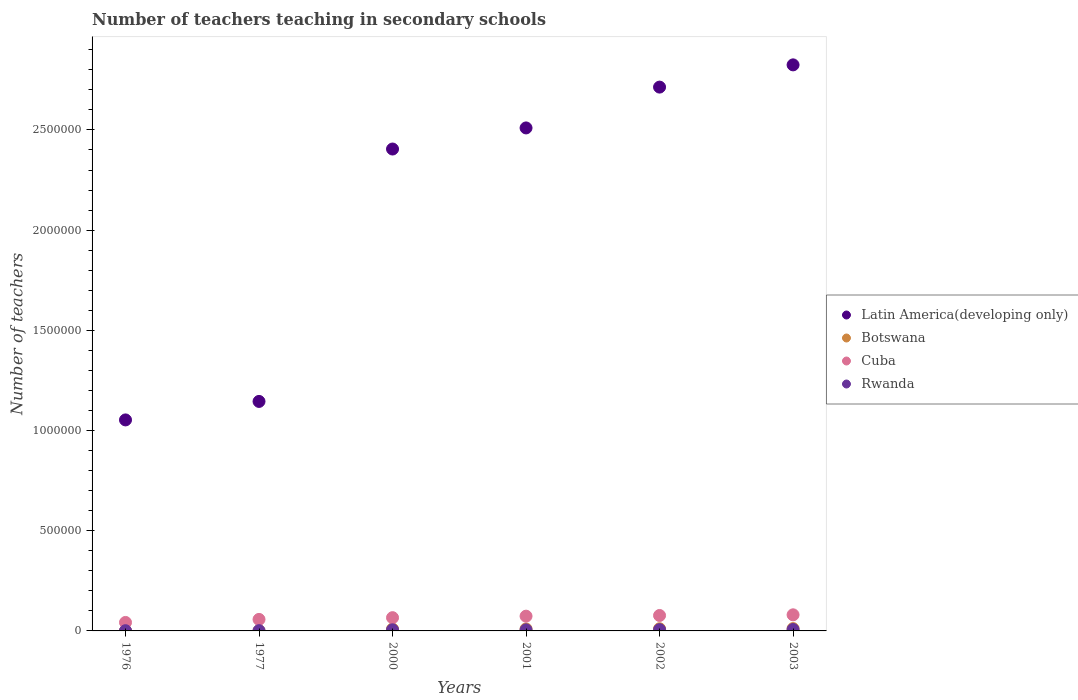How many different coloured dotlines are there?
Offer a very short reply. 4. What is the number of teachers teaching in secondary schools in Rwanda in 2002?
Offer a terse response. 6329. Across all years, what is the maximum number of teachers teaching in secondary schools in Botswana?
Offer a terse response. 1.16e+04. Across all years, what is the minimum number of teachers teaching in secondary schools in Latin America(developing only)?
Your answer should be compact. 1.05e+06. In which year was the number of teachers teaching in secondary schools in Botswana minimum?
Your response must be concise. 1976. What is the total number of teachers teaching in secondary schools in Cuba in the graph?
Give a very brief answer. 3.97e+05. What is the difference between the number of teachers teaching in secondary schools in Botswana in 1976 and that in 2002?
Ensure brevity in your answer.  -9895. What is the difference between the number of teachers teaching in secondary schools in Cuba in 2002 and the number of teachers teaching in secondary schools in Latin America(developing only) in 1976?
Your answer should be very brief. -9.76e+05. What is the average number of teachers teaching in secondary schools in Latin America(developing only) per year?
Give a very brief answer. 2.11e+06. In the year 1976, what is the difference between the number of teachers teaching in secondary schools in Rwanda and number of teachers teaching in secondary schools in Botswana?
Your answer should be compact. 213. In how many years, is the number of teachers teaching in secondary schools in Rwanda greater than 2300000?
Give a very brief answer. 0. What is the ratio of the number of teachers teaching in secondary schools in Cuba in 1976 to that in 2003?
Provide a succinct answer. 0.53. Is the number of teachers teaching in secondary schools in Rwanda in 1977 less than that in 2001?
Your answer should be compact. Yes. Is the difference between the number of teachers teaching in secondary schools in Rwanda in 1977 and 2003 greater than the difference between the number of teachers teaching in secondary schools in Botswana in 1977 and 2003?
Make the answer very short. Yes. What is the difference between the highest and the second highest number of teachers teaching in secondary schools in Rwanda?
Your answer should be very brief. 729. What is the difference between the highest and the lowest number of teachers teaching in secondary schools in Cuba?
Keep it short and to the point. 3.81e+04. In how many years, is the number of teachers teaching in secondary schools in Cuba greater than the average number of teachers teaching in secondary schools in Cuba taken over all years?
Make the answer very short. 3. Is it the case that in every year, the sum of the number of teachers teaching in secondary schools in Rwanda and number of teachers teaching in secondary schools in Latin America(developing only)  is greater than the number of teachers teaching in secondary schools in Botswana?
Keep it short and to the point. Yes. Does the number of teachers teaching in secondary schools in Cuba monotonically increase over the years?
Provide a succinct answer. Yes. Is the number of teachers teaching in secondary schools in Botswana strictly greater than the number of teachers teaching in secondary schools in Rwanda over the years?
Your response must be concise. No. How many years are there in the graph?
Give a very brief answer. 6. Are the values on the major ticks of Y-axis written in scientific E-notation?
Your response must be concise. No. What is the title of the graph?
Provide a short and direct response. Number of teachers teaching in secondary schools. Does "France" appear as one of the legend labels in the graph?
Keep it short and to the point. No. What is the label or title of the Y-axis?
Ensure brevity in your answer.  Number of teachers. What is the Number of teachers in Latin America(developing only) in 1976?
Ensure brevity in your answer.  1.05e+06. What is the Number of teachers of Botswana in 1976?
Ensure brevity in your answer.  920. What is the Number of teachers of Cuba in 1976?
Your answer should be compact. 4.23e+04. What is the Number of teachers in Rwanda in 1976?
Provide a short and direct response. 1133. What is the Number of teachers in Latin America(developing only) in 1977?
Keep it short and to the point. 1.15e+06. What is the Number of teachers of Botswana in 1977?
Keep it short and to the point. 928. What is the Number of teachers of Cuba in 1977?
Your answer should be compact. 5.75e+04. What is the Number of teachers of Rwanda in 1977?
Offer a terse response. 1285. What is the Number of teachers of Latin America(developing only) in 2000?
Give a very brief answer. 2.40e+06. What is the Number of teachers of Botswana in 2000?
Give a very brief answer. 9406. What is the Number of teachers of Cuba in 2000?
Your response must be concise. 6.61e+04. What is the Number of teachers in Rwanda in 2000?
Your answer should be very brief. 5557. What is the Number of teachers in Latin America(developing only) in 2001?
Offer a very short reply. 2.51e+06. What is the Number of teachers of Botswana in 2001?
Give a very brief answer. 9784. What is the Number of teachers in Cuba in 2001?
Make the answer very short. 7.36e+04. What is the Number of teachers of Rwanda in 2001?
Offer a very short reply. 5453. What is the Number of teachers in Latin America(developing only) in 2002?
Your response must be concise. 2.71e+06. What is the Number of teachers of Botswana in 2002?
Ensure brevity in your answer.  1.08e+04. What is the Number of teachers of Cuba in 2002?
Your answer should be very brief. 7.70e+04. What is the Number of teachers of Rwanda in 2002?
Give a very brief answer. 6329. What is the Number of teachers of Latin America(developing only) in 2003?
Ensure brevity in your answer.  2.82e+06. What is the Number of teachers in Botswana in 2003?
Your answer should be compact. 1.16e+04. What is the Number of teachers of Cuba in 2003?
Your response must be concise. 8.04e+04. What is the Number of teachers in Rwanda in 2003?
Your answer should be compact. 7058. Across all years, what is the maximum Number of teachers of Latin America(developing only)?
Offer a very short reply. 2.82e+06. Across all years, what is the maximum Number of teachers of Botswana?
Provide a succinct answer. 1.16e+04. Across all years, what is the maximum Number of teachers of Cuba?
Keep it short and to the point. 8.04e+04. Across all years, what is the maximum Number of teachers in Rwanda?
Make the answer very short. 7058. Across all years, what is the minimum Number of teachers in Latin America(developing only)?
Offer a terse response. 1.05e+06. Across all years, what is the minimum Number of teachers in Botswana?
Offer a terse response. 920. Across all years, what is the minimum Number of teachers of Cuba?
Offer a very short reply. 4.23e+04. Across all years, what is the minimum Number of teachers in Rwanda?
Ensure brevity in your answer.  1133. What is the total Number of teachers of Latin America(developing only) in the graph?
Offer a terse response. 1.27e+07. What is the total Number of teachers in Botswana in the graph?
Your answer should be compact. 4.35e+04. What is the total Number of teachers of Cuba in the graph?
Keep it short and to the point. 3.97e+05. What is the total Number of teachers of Rwanda in the graph?
Make the answer very short. 2.68e+04. What is the difference between the Number of teachers of Latin America(developing only) in 1976 and that in 1977?
Your answer should be very brief. -9.23e+04. What is the difference between the Number of teachers in Botswana in 1976 and that in 1977?
Provide a succinct answer. -8. What is the difference between the Number of teachers in Cuba in 1976 and that in 1977?
Offer a terse response. -1.52e+04. What is the difference between the Number of teachers of Rwanda in 1976 and that in 1977?
Give a very brief answer. -152. What is the difference between the Number of teachers in Latin America(developing only) in 1976 and that in 2000?
Offer a terse response. -1.35e+06. What is the difference between the Number of teachers of Botswana in 1976 and that in 2000?
Give a very brief answer. -8486. What is the difference between the Number of teachers of Cuba in 1976 and that in 2000?
Ensure brevity in your answer.  -2.38e+04. What is the difference between the Number of teachers in Rwanda in 1976 and that in 2000?
Offer a terse response. -4424. What is the difference between the Number of teachers of Latin America(developing only) in 1976 and that in 2001?
Give a very brief answer. -1.46e+06. What is the difference between the Number of teachers of Botswana in 1976 and that in 2001?
Your response must be concise. -8864. What is the difference between the Number of teachers of Cuba in 1976 and that in 2001?
Keep it short and to the point. -3.13e+04. What is the difference between the Number of teachers in Rwanda in 1976 and that in 2001?
Make the answer very short. -4320. What is the difference between the Number of teachers in Latin America(developing only) in 1976 and that in 2002?
Your answer should be very brief. -1.66e+06. What is the difference between the Number of teachers in Botswana in 1976 and that in 2002?
Offer a terse response. -9895. What is the difference between the Number of teachers in Cuba in 1976 and that in 2002?
Ensure brevity in your answer.  -3.47e+04. What is the difference between the Number of teachers in Rwanda in 1976 and that in 2002?
Make the answer very short. -5196. What is the difference between the Number of teachers of Latin America(developing only) in 1976 and that in 2003?
Your response must be concise. -1.77e+06. What is the difference between the Number of teachers in Botswana in 1976 and that in 2003?
Keep it short and to the point. -1.07e+04. What is the difference between the Number of teachers of Cuba in 1976 and that in 2003?
Provide a succinct answer. -3.81e+04. What is the difference between the Number of teachers in Rwanda in 1976 and that in 2003?
Offer a very short reply. -5925. What is the difference between the Number of teachers in Latin America(developing only) in 1977 and that in 2000?
Your response must be concise. -1.26e+06. What is the difference between the Number of teachers of Botswana in 1977 and that in 2000?
Your response must be concise. -8478. What is the difference between the Number of teachers in Cuba in 1977 and that in 2000?
Give a very brief answer. -8645. What is the difference between the Number of teachers of Rwanda in 1977 and that in 2000?
Your answer should be compact. -4272. What is the difference between the Number of teachers of Latin America(developing only) in 1977 and that in 2001?
Offer a very short reply. -1.36e+06. What is the difference between the Number of teachers in Botswana in 1977 and that in 2001?
Provide a succinct answer. -8856. What is the difference between the Number of teachers in Cuba in 1977 and that in 2001?
Your response must be concise. -1.62e+04. What is the difference between the Number of teachers in Rwanda in 1977 and that in 2001?
Your answer should be very brief. -4168. What is the difference between the Number of teachers in Latin America(developing only) in 1977 and that in 2002?
Your answer should be very brief. -1.57e+06. What is the difference between the Number of teachers in Botswana in 1977 and that in 2002?
Offer a very short reply. -9887. What is the difference between the Number of teachers of Cuba in 1977 and that in 2002?
Your response must be concise. -1.96e+04. What is the difference between the Number of teachers in Rwanda in 1977 and that in 2002?
Provide a short and direct response. -5044. What is the difference between the Number of teachers of Latin America(developing only) in 1977 and that in 2003?
Your answer should be compact. -1.68e+06. What is the difference between the Number of teachers of Botswana in 1977 and that in 2003?
Your response must be concise. -1.07e+04. What is the difference between the Number of teachers of Cuba in 1977 and that in 2003?
Offer a terse response. -2.29e+04. What is the difference between the Number of teachers of Rwanda in 1977 and that in 2003?
Your answer should be very brief. -5773. What is the difference between the Number of teachers of Latin America(developing only) in 2000 and that in 2001?
Provide a short and direct response. -1.05e+05. What is the difference between the Number of teachers of Botswana in 2000 and that in 2001?
Your answer should be compact. -378. What is the difference between the Number of teachers of Cuba in 2000 and that in 2001?
Make the answer very short. -7505. What is the difference between the Number of teachers of Rwanda in 2000 and that in 2001?
Provide a succinct answer. 104. What is the difference between the Number of teachers of Latin America(developing only) in 2000 and that in 2002?
Keep it short and to the point. -3.09e+05. What is the difference between the Number of teachers of Botswana in 2000 and that in 2002?
Offer a very short reply. -1409. What is the difference between the Number of teachers of Cuba in 2000 and that in 2002?
Ensure brevity in your answer.  -1.09e+04. What is the difference between the Number of teachers in Rwanda in 2000 and that in 2002?
Your answer should be very brief. -772. What is the difference between the Number of teachers of Latin America(developing only) in 2000 and that in 2003?
Give a very brief answer. -4.20e+05. What is the difference between the Number of teachers in Botswana in 2000 and that in 2003?
Keep it short and to the point. -2234. What is the difference between the Number of teachers of Cuba in 2000 and that in 2003?
Provide a succinct answer. -1.42e+04. What is the difference between the Number of teachers of Rwanda in 2000 and that in 2003?
Your answer should be very brief. -1501. What is the difference between the Number of teachers in Latin America(developing only) in 2001 and that in 2002?
Your answer should be compact. -2.04e+05. What is the difference between the Number of teachers in Botswana in 2001 and that in 2002?
Offer a terse response. -1031. What is the difference between the Number of teachers of Cuba in 2001 and that in 2002?
Offer a terse response. -3414. What is the difference between the Number of teachers of Rwanda in 2001 and that in 2002?
Your response must be concise. -876. What is the difference between the Number of teachers of Latin America(developing only) in 2001 and that in 2003?
Your answer should be compact. -3.15e+05. What is the difference between the Number of teachers in Botswana in 2001 and that in 2003?
Provide a succinct answer. -1856. What is the difference between the Number of teachers of Cuba in 2001 and that in 2003?
Provide a succinct answer. -6745. What is the difference between the Number of teachers of Rwanda in 2001 and that in 2003?
Your answer should be compact. -1605. What is the difference between the Number of teachers in Latin America(developing only) in 2002 and that in 2003?
Give a very brief answer. -1.11e+05. What is the difference between the Number of teachers of Botswana in 2002 and that in 2003?
Make the answer very short. -825. What is the difference between the Number of teachers of Cuba in 2002 and that in 2003?
Your answer should be very brief. -3331. What is the difference between the Number of teachers in Rwanda in 2002 and that in 2003?
Provide a succinct answer. -729. What is the difference between the Number of teachers of Latin America(developing only) in 1976 and the Number of teachers of Botswana in 1977?
Give a very brief answer. 1.05e+06. What is the difference between the Number of teachers of Latin America(developing only) in 1976 and the Number of teachers of Cuba in 1977?
Offer a terse response. 9.96e+05. What is the difference between the Number of teachers of Latin America(developing only) in 1976 and the Number of teachers of Rwanda in 1977?
Your response must be concise. 1.05e+06. What is the difference between the Number of teachers of Botswana in 1976 and the Number of teachers of Cuba in 1977?
Offer a terse response. -5.66e+04. What is the difference between the Number of teachers of Botswana in 1976 and the Number of teachers of Rwanda in 1977?
Offer a terse response. -365. What is the difference between the Number of teachers of Cuba in 1976 and the Number of teachers of Rwanda in 1977?
Your answer should be compact. 4.10e+04. What is the difference between the Number of teachers in Latin America(developing only) in 1976 and the Number of teachers in Botswana in 2000?
Your answer should be very brief. 1.04e+06. What is the difference between the Number of teachers of Latin America(developing only) in 1976 and the Number of teachers of Cuba in 2000?
Offer a terse response. 9.87e+05. What is the difference between the Number of teachers in Latin America(developing only) in 1976 and the Number of teachers in Rwanda in 2000?
Your answer should be very brief. 1.05e+06. What is the difference between the Number of teachers in Botswana in 1976 and the Number of teachers in Cuba in 2000?
Your response must be concise. -6.52e+04. What is the difference between the Number of teachers in Botswana in 1976 and the Number of teachers in Rwanda in 2000?
Your response must be concise. -4637. What is the difference between the Number of teachers of Cuba in 1976 and the Number of teachers of Rwanda in 2000?
Offer a terse response. 3.67e+04. What is the difference between the Number of teachers of Latin America(developing only) in 1976 and the Number of teachers of Botswana in 2001?
Offer a very short reply. 1.04e+06. What is the difference between the Number of teachers of Latin America(developing only) in 1976 and the Number of teachers of Cuba in 2001?
Offer a very short reply. 9.79e+05. What is the difference between the Number of teachers in Latin America(developing only) in 1976 and the Number of teachers in Rwanda in 2001?
Offer a terse response. 1.05e+06. What is the difference between the Number of teachers in Botswana in 1976 and the Number of teachers in Cuba in 2001?
Keep it short and to the point. -7.27e+04. What is the difference between the Number of teachers of Botswana in 1976 and the Number of teachers of Rwanda in 2001?
Provide a short and direct response. -4533. What is the difference between the Number of teachers in Cuba in 1976 and the Number of teachers in Rwanda in 2001?
Ensure brevity in your answer.  3.69e+04. What is the difference between the Number of teachers in Latin America(developing only) in 1976 and the Number of teachers in Botswana in 2002?
Provide a short and direct response. 1.04e+06. What is the difference between the Number of teachers of Latin America(developing only) in 1976 and the Number of teachers of Cuba in 2002?
Keep it short and to the point. 9.76e+05. What is the difference between the Number of teachers in Latin America(developing only) in 1976 and the Number of teachers in Rwanda in 2002?
Make the answer very short. 1.05e+06. What is the difference between the Number of teachers of Botswana in 1976 and the Number of teachers of Cuba in 2002?
Offer a very short reply. -7.61e+04. What is the difference between the Number of teachers in Botswana in 1976 and the Number of teachers in Rwanda in 2002?
Give a very brief answer. -5409. What is the difference between the Number of teachers of Cuba in 1976 and the Number of teachers of Rwanda in 2002?
Provide a succinct answer. 3.60e+04. What is the difference between the Number of teachers in Latin America(developing only) in 1976 and the Number of teachers in Botswana in 2003?
Provide a short and direct response. 1.04e+06. What is the difference between the Number of teachers of Latin America(developing only) in 1976 and the Number of teachers of Cuba in 2003?
Ensure brevity in your answer.  9.73e+05. What is the difference between the Number of teachers in Latin America(developing only) in 1976 and the Number of teachers in Rwanda in 2003?
Your answer should be compact. 1.05e+06. What is the difference between the Number of teachers in Botswana in 1976 and the Number of teachers in Cuba in 2003?
Make the answer very short. -7.95e+04. What is the difference between the Number of teachers of Botswana in 1976 and the Number of teachers of Rwanda in 2003?
Ensure brevity in your answer.  -6138. What is the difference between the Number of teachers of Cuba in 1976 and the Number of teachers of Rwanda in 2003?
Provide a short and direct response. 3.52e+04. What is the difference between the Number of teachers of Latin America(developing only) in 1977 and the Number of teachers of Botswana in 2000?
Ensure brevity in your answer.  1.14e+06. What is the difference between the Number of teachers of Latin America(developing only) in 1977 and the Number of teachers of Cuba in 2000?
Provide a succinct answer. 1.08e+06. What is the difference between the Number of teachers of Latin America(developing only) in 1977 and the Number of teachers of Rwanda in 2000?
Provide a short and direct response. 1.14e+06. What is the difference between the Number of teachers of Botswana in 1977 and the Number of teachers of Cuba in 2000?
Offer a terse response. -6.52e+04. What is the difference between the Number of teachers of Botswana in 1977 and the Number of teachers of Rwanda in 2000?
Offer a terse response. -4629. What is the difference between the Number of teachers in Cuba in 1977 and the Number of teachers in Rwanda in 2000?
Make the answer very short. 5.19e+04. What is the difference between the Number of teachers in Latin America(developing only) in 1977 and the Number of teachers in Botswana in 2001?
Provide a short and direct response. 1.14e+06. What is the difference between the Number of teachers of Latin America(developing only) in 1977 and the Number of teachers of Cuba in 2001?
Provide a succinct answer. 1.07e+06. What is the difference between the Number of teachers of Latin America(developing only) in 1977 and the Number of teachers of Rwanda in 2001?
Your answer should be very brief. 1.14e+06. What is the difference between the Number of teachers in Botswana in 1977 and the Number of teachers in Cuba in 2001?
Provide a succinct answer. -7.27e+04. What is the difference between the Number of teachers of Botswana in 1977 and the Number of teachers of Rwanda in 2001?
Offer a terse response. -4525. What is the difference between the Number of teachers of Cuba in 1977 and the Number of teachers of Rwanda in 2001?
Provide a succinct answer. 5.20e+04. What is the difference between the Number of teachers of Latin America(developing only) in 1977 and the Number of teachers of Botswana in 2002?
Your response must be concise. 1.13e+06. What is the difference between the Number of teachers in Latin America(developing only) in 1977 and the Number of teachers in Cuba in 2002?
Your answer should be very brief. 1.07e+06. What is the difference between the Number of teachers in Latin America(developing only) in 1977 and the Number of teachers in Rwanda in 2002?
Provide a short and direct response. 1.14e+06. What is the difference between the Number of teachers of Botswana in 1977 and the Number of teachers of Cuba in 2002?
Ensure brevity in your answer.  -7.61e+04. What is the difference between the Number of teachers in Botswana in 1977 and the Number of teachers in Rwanda in 2002?
Your answer should be compact. -5401. What is the difference between the Number of teachers in Cuba in 1977 and the Number of teachers in Rwanda in 2002?
Make the answer very short. 5.11e+04. What is the difference between the Number of teachers in Latin America(developing only) in 1977 and the Number of teachers in Botswana in 2003?
Make the answer very short. 1.13e+06. What is the difference between the Number of teachers in Latin America(developing only) in 1977 and the Number of teachers in Cuba in 2003?
Keep it short and to the point. 1.06e+06. What is the difference between the Number of teachers of Latin America(developing only) in 1977 and the Number of teachers of Rwanda in 2003?
Keep it short and to the point. 1.14e+06. What is the difference between the Number of teachers in Botswana in 1977 and the Number of teachers in Cuba in 2003?
Your response must be concise. -7.94e+04. What is the difference between the Number of teachers of Botswana in 1977 and the Number of teachers of Rwanda in 2003?
Your answer should be very brief. -6130. What is the difference between the Number of teachers of Cuba in 1977 and the Number of teachers of Rwanda in 2003?
Your answer should be very brief. 5.04e+04. What is the difference between the Number of teachers of Latin America(developing only) in 2000 and the Number of teachers of Botswana in 2001?
Offer a terse response. 2.40e+06. What is the difference between the Number of teachers of Latin America(developing only) in 2000 and the Number of teachers of Cuba in 2001?
Provide a short and direct response. 2.33e+06. What is the difference between the Number of teachers of Latin America(developing only) in 2000 and the Number of teachers of Rwanda in 2001?
Offer a very short reply. 2.40e+06. What is the difference between the Number of teachers in Botswana in 2000 and the Number of teachers in Cuba in 2001?
Make the answer very short. -6.42e+04. What is the difference between the Number of teachers of Botswana in 2000 and the Number of teachers of Rwanda in 2001?
Your answer should be very brief. 3953. What is the difference between the Number of teachers in Cuba in 2000 and the Number of teachers in Rwanda in 2001?
Provide a short and direct response. 6.07e+04. What is the difference between the Number of teachers in Latin America(developing only) in 2000 and the Number of teachers in Botswana in 2002?
Your answer should be compact. 2.39e+06. What is the difference between the Number of teachers in Latin America(developing only) in 2000 and the Number of teachers in Cuba in 2002?
Offer a very short reply. 2.33e+06. What is the difference between the Number of teachers of Latin America(developing only) in 2000 and the Number of teachers of Rwanda in 2002?
Your answer should be very brief. 2.40e+06. What is the difference between the Number of teachers in Botswana in 2000 and the Number of teachers in Cuba in 2002?
Ensure brevity in your answer.  -6.76e+04. What is the difference between the Number of teachers of Botswana in 2000 and the Number of teachers of Rwanda in 2002?
Offer a terse response. 3077. What is the difference between the Number of teachers of Cuba in 2000 and the Number of teachers of Rwanda in 2002?
Ensure brevity in your answer.  5.98e+04. What is the difference between the Number of teachers of Latin America(developing only) in 2000 and the Number of teachers of Botswana in 2003?
Ensure brevity in your answer.  2.39e+06. What is the difference between the Number of teachers of Latin America(developing only) in 2000 and the Number of teachers of Cuba in 2003?
Offer a very short reply. 2.32e+06. What is the difference between the Number of teachers in Latin America(developing only) in 2000 and the Number of teachers in Rwanda in 2003?
Offer a terse response. 2.40e+06. What is the difference between the Number of teachers in Botswana in 2000 and the Number of teachers in Cuba in 2003?
Ensure brevity in your answer.  -7.10e+04. What is the difference between the Number of teachers in Botswana in 2000 and the Number of teachers in Rwanda in 2003?
Offer a terse response. 2348. What is the difference between the Number of teachers of Cuba in 2000 and the Number of teachers of Rwanda in 2003?
Offer a terse response. 5.91e+04. What is the difference between the Number of teachers of Latin America(developing only) in 2001 and the Number of teachers of Botswana in 2002?
Give a very brief answer. 2.50e+06. What is the difference between the Number of teachers in Latin America(developing only) in 2001 and the Number of teachers in Cuba in 2002?
Your answer should be compact. 2.43e+06. What is the difference between the Number of teachers in Latin America(developing only) in 2001 and the Number of teachers in Rwanda in 2002?
Your response must be concise. 2.50e+06. What is the difference between the Number of teachers of Botswana in 2001 and the Number of teachers of Cuba in 2002?
Offer a very short reply. -6.73e+04. What is the difference between the Number of teachers of Botswana in 2001 and the Number of teachers of Rwanda in 2002?
Make the answer very short. 3455. What is the difference between the Number of teachers in Cuba in 2001 and the Number of teachers in Rwanda in 2002?
Keep it short and to the point. 6.73e+04. What is the difference between the Number of teachers of Latin America(developing only) in 2001 and the Number of teachers of Botswana in 2003?
Provide a short and direct response. 2.50e+06. What is the difference between the Number of teachers of Latin America(developing only) in 2001 and the Number of teachers of Cuba in 2003?
Provide a short and direct response. 2.43e+06. What is the difference between the Number of teachers in Latin America(developing only) in 2001 and the Number of teachers in Rwanda in 2003?
Keep it short and to the point. 2.50e+06. What is the difference between the Number of teachers of Botswana in 2001 and the Number of teachers of Cuba in 2003?
Offer a very short reply. -7.06e+04. What is the difference between the Number of teachers in Botswana in 2001 and the Number of teachers in Rwanda in 2003?
Offer a terse response. 2726. What is the difference between the Number of teachers in Cuba in 2001 and the Number of teachers in Rwanda in 2003?
Ensure brevity in your answer.  6.66e+04. What is the difference between the Number of teachers of Latin America(developing only) in 2002 and the Number of teachers of Botswana in 2003?
Keep it short and to the point. 2.70e+06. What is the difference between the Number of teachers in Latin America(developing only) in 2002 and the Number of teachers in Cuba in 2003?
Your answer should be very brief. 2.63e+06. What is the difference between the Number of teachers of Latin America(developing only) in 2002 and the Number of teachers of Rwanda in 2003?
Keep it short and to the point. 2.71e+06. What is the difference between the Number of teachers in Botswana in 2002 and the Number of teachers in Cuba in 2003?
Provide a succinct answer. -6.96e+04. What is the difference between the Number of teachers of Botswana in 2002 and the Number of teachers of Rwanda in 2003?
Provide a succinct answer. 3757. What is the difference between the Number of teachers in Cuba in 2002 and the Number of teachers in Rwanda in 2003?
Offer a terse response. 7.00e+04. What is the average Number of teachers of Latin America(developing only) per year?
Make the answer very short. 2.11e+06. What is the average Number of teachers of Botswana per year?
Offer a very short reply. 7248.83. What is the average Number of teachers in Cuba per year?
Provide a short and direct response. 6.62e+04. What is the average Number of teachers of Rwanda per year?
Offer a terse response. 4469.17. In the year 1976, what is the difference between the Number of teachers of Latin America(developing only) and Number of teachers of Botswana?
Make the answer very short. 1.05e+06. In the year 1976, what is the difference between the Number of teachers of Latin America(developing only) and Number of teachers of Cuba?
Your answer should be very brief. 1.01e+06. In the year 1976, what is the difference between the Number of teachers in Latin America(developing only) and Number of teachers in Rwanda?
Your response must be concise. 1.05e+06. In the year 1976, what is the difference between the Number of teachers of Botswana and Number of teachers of Cuba?
Offer a very short reply. -4.14e+04. In the year 1976, what is the difference between the Number of teachers of Botswana and Number of teachers of Rwanda?
Keep it short and to the point. -213. In the year 1976, what is the difference between the Number of teachers of Cuba and Number of teachers of Rwanda?
Your answer should be compact. 4.12e+04. In the year 1977, what is the difference between the Number of teachers of Latin America(developing only) and Number of teachers of Botswana?
Offer a terse response. 1.14e+06. In the year 1977, what is the difference between the Number of teachers in Latin America(developing only) and Number of teachers in Cuba?
Provide a short and direct response. 1.09e+06. In the year 1977, what is the difference between the Number of teachers of Latin America(developing only) and Number of teachers of Rwanda?
Ensure brevity in your answer.  1.14e+06. In the year 1977, what is the difference between the Number of teachers of Botswana and Number of teachers of Cuba?
Your response must be concise. -5.65e+04. In the year 1977, what is the difference between the Number of teachers in Botswana and Number of teachers in Rwanda?
Provide a succinct answer. -357. In the year 1977, what is the difference between the Number of teachers in Cuba and Number of teachers in Rwanda?
Offer a very short reply. 5.62e+04. In the year 2000, what is the difference between the Number of teachers in Latin America(developing only) and Number of teachers in Botswana?
Provide a short and direct response. 2.40e+06. In the year 2000, what is the difference between the Number of teachers in Latin America(developing only) and Number of teachers in Cuba?
Give a very brief answer. 2.34e+06. In the year 2000, what is the difference between the Number of teachers in Latin America(developing only) and Number of teachers in Rwanda?
Your answer should be compact. 2.40e+06. In the year 2000, what is the difference between the Number of teachers in Botswana and Number of teachers in Cuba?
Offer a very short reply. -5.67e+04. In the year 2000, what is the difference between the Number of teachers in Botswana and Number of teachers in Rwanda?
Offer a terse response. 3849. In the year 2000, what is the difference between the Number of teachers in Cuba and Number of teachers in Rwanda?
Keep it short and to the point. 6.06e+04. In the year 2001, what is the difference between the Number of teachers in Latin America(developing only) and Number of teachers in Botswana?
Your answer should be compact. 2.50e+06. In the year 2001, what is the difference between the Number of teachers of Latin America(developing only) and Number of teachers of Cuba?
Offer a terse response. 2.44e+06. In the year 2001, what is the difference between the Number of teachers of Latin America(developing only) and Number of teachers of Rwanda?
Your answer should be very brief. 2.50e+06. In the year 2001, what is the difference between the Number of teachers in Botswana and Number of teachers in Cuba?
Your answer should be compact. -6.38e+04. In the year 2001, what is the difference between the Number of teachers in Botswana and Number of teachers in Rwanda?
Keep it short and to the point. 4331. In the year 2001, what is the difference between the Number of teachers of Cuba and Number of teachers of Rwanda?
Your answer should be very brief. 6.82e+04. In the year 2002, what is the difference between the Number of teachers of Latin America(developing only) and Number of teachers of Botswana?
Give a very brief answer. 2.70e+06. In the year 2002, what is the difference between the Number of teachers in Latin America(developing only) and Number of teachers in Cuba?
Offer a very short reply. 2.64e+06. In the year 2002, what is the difference between the Number of teachers in Latin America(developing only) and Number of teachers in Rwanda?
Give a very brief answer. 2.71e+06. In the year 2002, what is the difference between the Number of teachers in Botswana and Number of teachers in Cuba?
Offer a very short reply. -6.62e+04. In the year 2002, what is the difference between the Number of teachers in Botswana and Number of teachers in Rwanda?
Ensure brevity in your answer.  4486. In the year 2002, what is the difference between the Number of teachers in Cuba and Number of teachers in Rwanda?
Offer a very short reply. 7.07e+04. In the year 2003, what is the difference between the Number of teachers of Latin America(developing only) and Number of teachers of Botswana?
Offer a terse response. 2.81e+06. In the year 2003, what is the difference between the Number of teachers of Latin America(developing only) and Number of teachers of Cuba?
Your answer should be compact. 2.74e+06. In the year 2003, what is the difference between the Number of teachers in Latin America(developing only) and Number of teachers in Rwanda?
Offer a terse response. 2.82e+06. In the year 2003, what is the difference between the Number of teachers of Botswana and Number of teachers of Cuba?
Make the answer very short. -6.87e+04. In the year 2003, what is the difference between the Number of teachers in Botswana and Number of teachers in Rwanda?
Keep it short and to the point. 4582. In the year 2003, what is the difference between the Number of teachers in Cuba and Number of teachers in Rwanda?
Your response must be concise. 7.33e+04. What is the ratio of the Number of teachers in Latin America(developing only) in 1976 to that in 1977?
Provide a succinct answer. 0.92. What is the ratio of the Number of teachers of Cuba in 1976 to that in 1977?
Provide a succinct answer. 0.74. What is the ratio of the Number of teachers of Rwanda in 1976 to that in 1977?
Provide a succinct answer. 0.88. What is the ratio of the Number of teachers in Latin America(developing only) in 1976 to that in 2000?
Offer a very short reply. 0.44. What is the ratio of the Number of teachers in Botswana in 1976 to that in 2000?
Keep it short and to the point. 0.1. What is the ratio of the Number of teachers of Cuba in 1976 to that in 2000?
Ensure brevity in your answer.  0.64. What is the ratio of the Number of teachers in Rwanda in 1976 to that in 2000?
Provide a succinct answer. 0.2. What is the ratio of the Number of teachers of Latin America(developing only) in 1976 to that in 2001?
Ensure brevity in your answer.  0.42. What is the ratio of the Number of teachers of Botswana in 1976 to that in 2001?
Provide a succinct answer. 0.09. What is the ratio of the Number of teachers of Cuba in 1976 to that in 2001?
Make the answer very short. 0.57. What is the ratio of the Number of teachers of Rwanda in 1976 to that in 2001?
Give a very brief answer. 0.21. What is the ratio of the Number of teachers in Latin America(developing only) in 1976 to that in 2002?
Provide a short and direct response. 0.39. What is the ratio of the Number of teachers in Botswana in 1976 to that in 2002?
Your answer should be compact. 0.09. What is the ratio of the Number of teachers in Cuba in 1976 to that in 2002?
Your response must be concise. 0.55. What is the ratio of the Number of teachers in Rwanda in 1976 to that in 2002?
Keep it short and to the point. 0.18. What is the ratio of the Number of teachers of Latin America(developing only) in 1976 to that in 2003?
Provide a short and direct response. 0.37. What is the ratio of the Number of teachers of Botswana in 1976 to that in 2003?
Keep it short and to the point. 0.08. What is the ratio of the Number of teachers of Cuba in 1976 to that in 2003?
Your answer should be compact. 0.53. What is the ratio of the Number of teachers in Rwanda in 1976 to that in 2003?
Keep it short and to the point. 0.16. What is the ratio of the Number of teachers in Latin America(developing only) in 1977 to that in 2000?
Offer a very short reply. 0.48. What is the ratio of the Number of teachers in Botswana in 1977 to that in 2000?
Your answer should be very brief. 0.1. What is the ratio of the Number of teachers of Cuba in 1977 to that in 2000?
Provide a succinct answer. 0.87. What is the ratio of the Number of teachers of Rwanda in 1977 to that in 2000?
Offer a terse response. 0.23. What is the ratio of the Number of teachers in Latin America(developing only) in 1977 to that in 2001?
Your answer should be compact. 0.46. What is the ratio of the Number of teachers of Botswana in 1977 to that in 2001?
Your response must be concise. 0.09. What is the ratio of the Number of teachers of Cuba in 1977 to that in 2001?
Your answer should be very brief. 0.78. What is the ratio of the Number of teachers in Rwanda in 1977 to that in 2001?
Your answer should be very brief. 0.24. What is the ratio of the Number of teachers of Latin America(developing only) in 1977 to that in 2002?
Ensure brevity in your answer.  0.42. What is the ratio of the Number of teachers of Botswana in 1977 to that in 2002?
Keep it short and to the point. 0.09. What is the ratio of the Number of teachers in Cuba in 1977 to that in 2002?
Make the answer very short. 0.75. What is the ratio of the Number of teachers of Rwanda in 1977 to that in 2002?
Your answer should be compact. 0.2. What is the ratio of the Number of teachers of Latin America(developing only) in 1977 to that in 2003?
Make the answer very short. 0.41. What is the ratio of the Number of teachers in Botswana in 1977 to that in 2003?
Your answer should be very brief. 0.08. What is the ratio of the Number of teachers in Cuba in 1977 to that in 2003?
Provide a short and direct response. 0.72. What is the ratio of the Number of teachers in Rwanda in 1977 to that in 2003?
Ensure brevity in your answer.  0.18. What is the ratio of the Number of teachers of Latin America(developing only) in 2000 to that in 2001?
Keep it short and to the point. 0.96. What is the ratio of the Number of teachers of Botswana in 2000 to that in 2001?
Offer a terse response. 0.96. What is the ratio of the Number of teachers in Cuba in 2000 to that in 2001?
Ensure brevity in your answer.  0.9. What is the ratio of the Number of teachers in Rwanda in 2000 to that in 2001?
Offer a very short reply. 1.02. What is the ratio of the Number of teachers in Latin America(developing only) in 2000 to that in 2002?
Make the answer very short. 0.89. What is the ratio of the Number of teachers in Botswana in 2000 to that in 2002?
Offer a very short reply. 0.87. What is the ratio of the Number of teachers of Cuba in 2000 to that in 2002?
Make the answer very short. 0.86. What is the ratio of the Number of teachers in Rwanda in 2000 to that in 2002?
Ensure brevity in your answer.  0.88. What is the ratio of the Number of teachers in Latin America(developing only) in 2000 to that in 2003?
Ensure brevity in your answer.  0.85. What is the ratio of the Number of teachers in Botswana in 2000 to that in 2003?
Your answer should be compact. 0.81. What is the ratio of the Number of teachers of Cuba in 2000 to that in 2003?
Provide a short and direct response. 0.82. What is the ratio of the Number of teachers in Rwanda in 2000 to that in 2003?
Give a very brief answer. 0.79. What is the ratio of the Number of teachers of Latin America(developing only) in 2001 to that in 2002?
Offer a terse response. 0.92. What is the ratio of the Number of teachers in Botswana in 2001 to that in 2002?
Offer a very short reply. 0.9. What is the ratio of the Number of teachers in Cuba in 2001 to that in 2002?
Offer a very short reply. 0.96. What is the ratio of the Number of teachers in Rwanda in 2001 to that in 2002?
Offer a terse response. 0.86. What is the ratio of the Number of teachers of Latin America(developing only) in 2001 to that in 2003?
Your answer should be very brief. 0.89. What is the ratio of the Number of teachers in Botswana in 2001 to that in 2003?
Provide a succinct answer. 0.84. What is the ratio of the Number of teachers in Cuba in 2001 to that in 2003?
Ensure brevity in your answer.  0.92. What is the ratio of the Number of teachers of Rwanda in 2001 to that in 2003?
Your answer should be compact. 0.77. What is the ratio of the Number of teachers of Latin America(developing only) in 2002 to that in 2003?
Offer a very short reply. 0.96. What is the ratio of the Number of teachers in Botswana in 2002 to that in 2003?
Your answer should be compact. 0.93. What is the ratio of the Number of teachers of Cuba in 2002 to that in 2003?
Your response must be concise. 0.96. What is the ratio of the Number of teachers of Rwanda in 2002 to that in 2003?
Keep it short and to the point. 0.9. What is the difference between the highest and the second highest Number of teachers in Latin America(developing only)?
Make the answer very short. 1.11e+05. What is the difference between the highest and the second highest Number of teachers of Botswana?
Your answer should be very brief. 825. What is the difference between the highest and the second highest Number of teachers of Cuba?
Give a very brief answer. 3331. What is the difference between the highest and the second highest Number of teachers in Rwanda?
Your answer should be very brief. 729. What is the difference between the highest and the lowest Number of teachers in Latin America(developing only)?
Your answer should be very brief. 1.77e+06. What is the difference between the highest and the lowest Number of teachers in Botswana?
Provide a succinct answer. 1.07e+04. What is the difference between the highest and the lowest Number of teachers in Cuba?
Your response must be concise. 3.81e+04. What is the difference between the highest and the lowest Number of teachers of Rwanda?
Your answer should be very brief. 5925. 